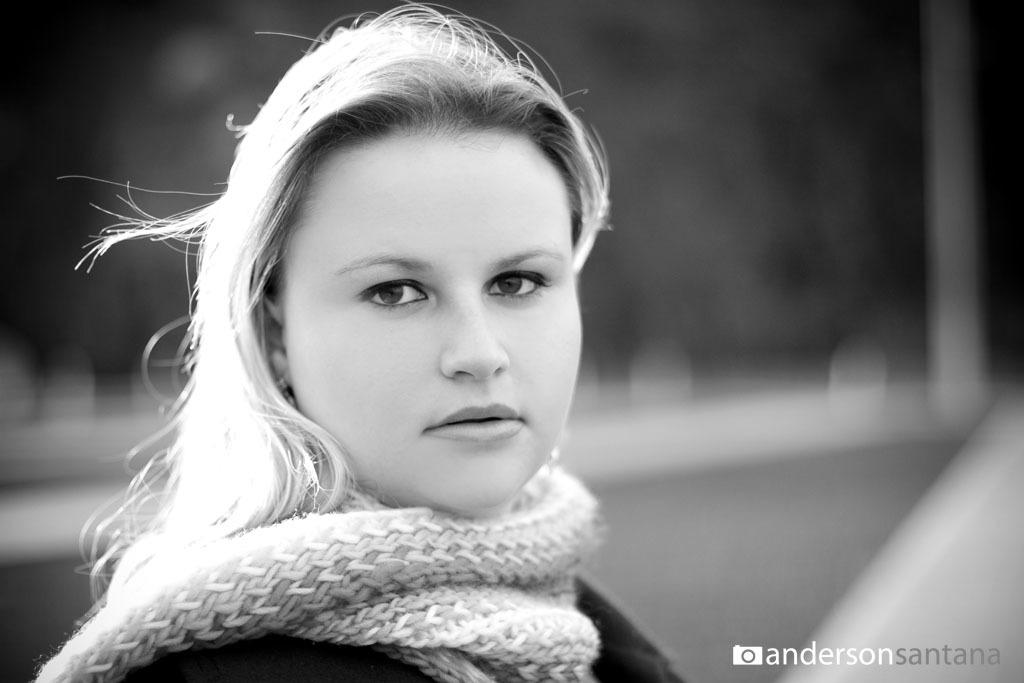Who is the main subject in the foreground of the image? There is a woman in the foreground of the image. What is the woman wearing in the image? The woman is wearing a scarf. Can you describe the background of the image? The background of the image is blurred. What type of room is visible in the background of the image? There is no room visible in the background of the image, as it is blurred. How many rings is the woman wearing on her fingers in the image? There is no information about rings in the image, as the focus is on the woman wearing a scarf. 